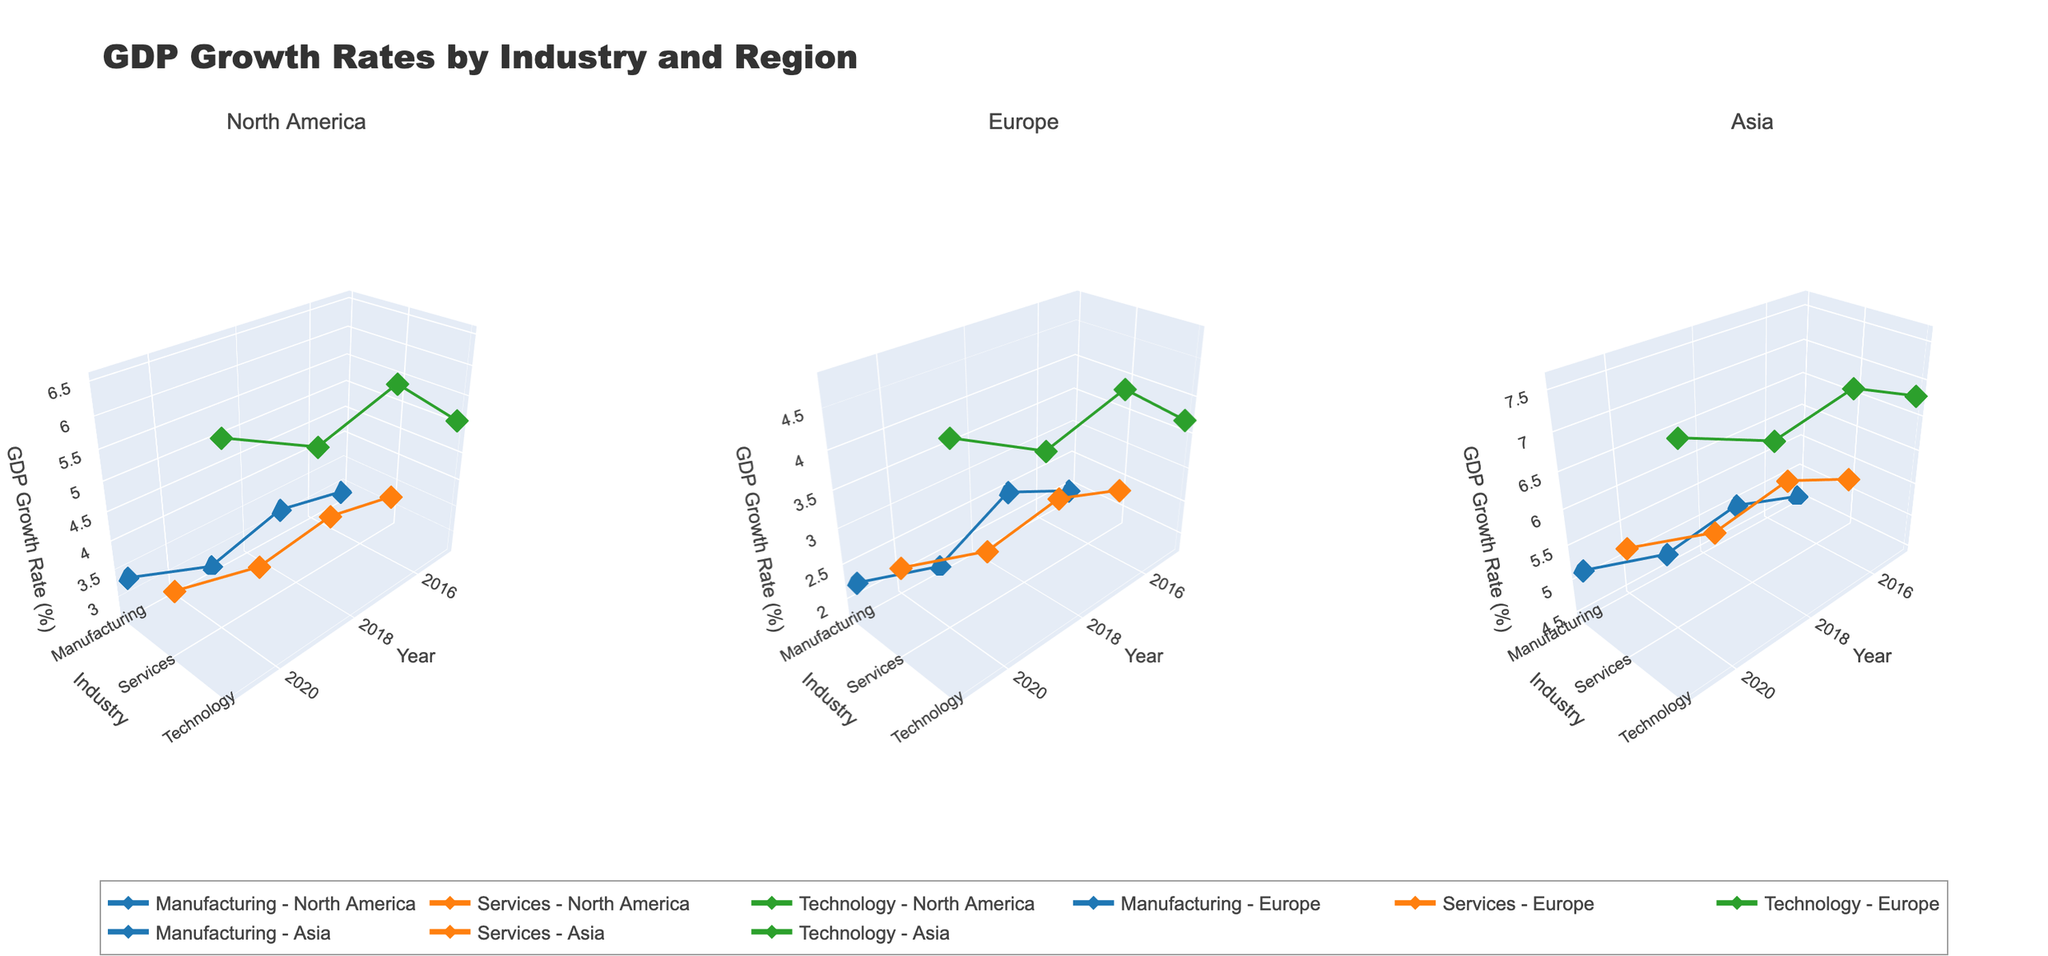What is the title of the figure? The title is displayed at the top of the figure. It indicates what the figure is about.
Answer: GDP Growth Rates by Industry and Region Which industry had the highest GDP growth rate in North America in 2021? From the subplot specific to North America, look at the GDP growth rates for each industry in 2021. The Technology industry shows the highest value.
Answer: Technology How did the GDP growth rate for the Manufacturing industry in Asia change from 2015 to 2021? Follow the line for the Manufacturing industry in the Asia subplot from 2015 to 2021. The growth rate increased from 4.5% in 2015 to 5.1% in 2021.
Answer: Increased Compare the GDP growth rates between Services and Technology industries in Europe in 2017. Which had a higher growth rate? Look at the data points for 2017 in the Europe subplot. The Technology industry has a higher growth rate (4.5%) compared to the Services industry (2.7%).
Answer: Technology What is the average GDP growth rate for the Technology industry in North America for the years provided? Identify the GDP growth rates for the Technology industry in North America for each year: 2015 (5.1%), 2017 (6.2%), 2019 (5.8%), and 2021 (6.5%). Calculate the average: (5.1 + 6.2 + 5.8 + 6.5) / 4 = 5.9%.
Answer: 5.9% Which region had the highest GDP growth rate for the Services industry in 2019? Look at the GDP growth rates for the Services industry in each region for 2019. Asia has the highest rate at 5.5%.
Answer: Asia In which year did the Manufacturing industry in Europe experience the lowest GDP growth rate, based on the figure? Check the GDP growth rates for the Manufacturing industry in Europe for each year. The lowest rate is in 2019 at 1.8%.
Answer: 2019 What trend can be observed in the GDP growth rates of the Technology industry in Asia from 2015 to 2021? Examine the data points for the Technology industry in Asia over the years provided. The growth rate shows a consistent increase from 6.8% in 2015 to 7.6% in 2021.
Answer: Consistent increase How does the GDP growth rate of the Services industry in North America from 2015 to 2021 compare to that in Europe? Compare the growth rates for the Services industry in North America and Europe for the years 2015 to 2021. North America's growth rates are consistently higher than Europe's during these years.
Answer: Higher in North America Which industry shows the most variability in GDP growth rates across all regions from 2015 to 2021? Compare the ranges of GDP growth rates for all industries across all regions. The Technology industry shows the most variability, ranging from 3.7% in Europe (2015) to 7.6% in Asia (2021).
Answer: Technology 